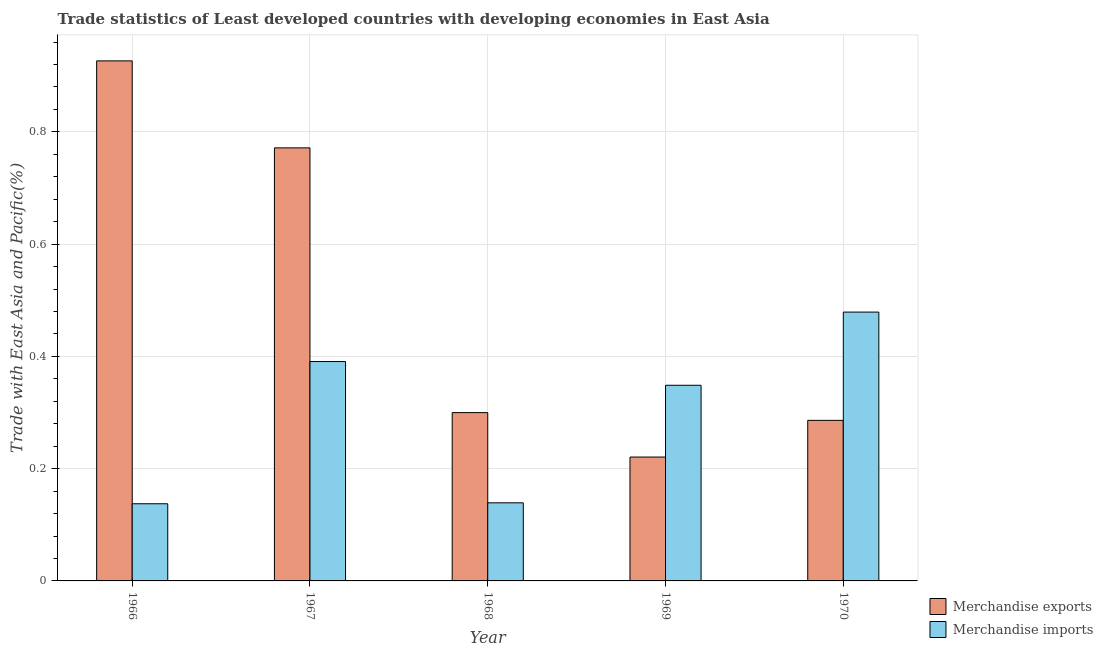How many groups of bars are there?
Ensure brevity in your answer.  5. How many bars are there on the 2nd tick from the left?
Your answer should be very brief. 2. In how many cases, is the number of bars for a given year not equal to the number of legend labels?
Your answer should be compact. 0. What is the merchandise exports in 1970?
Your answer should be very brief. 0.29. Across all years, what is the maximum merchandise imports?
Offer a terse response. 0.48. Across all years, what is the minimum merchandise imports?
Give a very brief answer. 0.14. In which year was the merchandise exports maximum?
Keep it short and to the point. 1966. In which year was the merchandise exports minimum?
Ensure brevity in your answer.  1969. What is the total merchandise imports in the graph?
Your answer should be very brief. 1.49. What is the difference between the merchandise imports in 1967 and that in 1970?
Your response must be concise. -0.09. What is the difference between the merchandise exports in 1966 and the merchandise imports in 1967?
Keep it short and to the point. 0.15. What is the average merchandise imports per year?
Make the answer very short. 0.3. In how many years, is the merchandise imports greater than 0.04 %?
Ensure brevity in your answer.  5. What is the ratio of the merchandise imports in 1966 to that in 1968?
Your answer should be very brief. 0.99. Is the difference between the merchandise exports in 1967 and 1970 greater than the difference between the merchandise imports in 1967 and 1970?
Ensure brevity in your answer.  No. What is the difference between the highest and the second highest merchandise exports?
Keep it short and to the point. 0.15. What is the difference between the highest and the lowest merchandise imports?
Make the answer very short. 0.34. Is the sum of the merchandise exports in 1966 and 1970 greater than the maximum merchandise imports across all years?
Your response must be concise. Yes. What does the 2nd bar from the left in 1967 represents?
Offer a terse response. Merchandise imports. Are all the bars in the graph horizontal?
Keep it short and to the point. No. Are the values on the major ticks of Y-axis written in scientific E-notation?
Ensure brevity in your answer.  No. Does the graph contain any zero values?
Your answer should be compact. No. Does the graph contain grids?
Make the answer very short. Yes. How are the legend labels stacked?
Provide a short and direct response. Vertical. What is the title of the graph?
Keep it short and to the point. Trade statistics of Least developed countries with developing economies in East Asia. What is the label or title of the Y-axis?
Ensure brevity in your answer.  Trade with East Asia and Pacific(%). What is the Trade with East Asia and Pacific(%) in Merchandise exports in 1966?
Your response must be concise. 0.93. What is the Trade with East Asia and Pacific(%) of Merchandise imports in 1966?
Keep it short and to the point. 0.14. What is the Trade with East Asia and Pacific(%) of Merchandise exports in 1967?
Make the answer very short. 0.77. What is the Trade with East Asia and Pacific(%) of Merchandise imports in 1967?
Make the answer very short. 0.39. What is the Trade with East Asia and Pacific(%) in Merchandise exports in 1968?
Your response must be concise. 0.3. What is the Trade with East Asia and Pacific(%) of Merchandise imports in 1968?
Your answer should be compact. 0.14. What is the Trade with East Asia and Pacific(%) of Merchandise exports in 1969?
Keep it short and to the point. 0.22. What is the Trade with East Asia and Pacific(%) of Merchandise imports in 1969?
Offer a very short reply. 0.35. What is the Trade with East Asia and Pacific(%) of Merchandise exports in 1970?
Ensure brevity in your answer.  0.29. What is the Trade with East Asia and Pacific(%) of Merchandise imports in 1970?
Your response must be concise. 0.48. Across all years, what is the maximum Trade with East Asia and Pacific(%) in Merchandise exports?
Offer a very short reply. 0.93. Across all years, what is the maximum Trade with East Asia and Pacific(%) in Merchandise imports?
Keep it short and to the point. 0.48. Across all years, what is the minimum Trade with East Asia and Pacific(%) of Merchandise exports?
Give a very brief answer. 0.22. Across all years, what is the minimum Trade with East Asia and Pacific(%) in Merchandise imports?
Provide a short and direct response. 0.14. What is the total Trade with East Asia and Pacific(%) of Merchandise exports in the graph?
Your response must be concise. 2.5. What is the total Trade with East Asia and Pacific(%) in Merchandise imports in the graph?
Your response must be concise. 1.49. What is the difference between the Trade with East Asia and Pacific(%) of Merchandise exports in 1966 and that in 1967?
Ensure brevity in your answer.  0.15. What is the difference between the Trade with East Asia and Pacific(%) in Merchandise imports in 1966 and that in 1967?
Offer a terse response. -0.25. What is the difference between the Trade with East Asia and Pacific(%) of Merchandise exports in 1966 and that in 1968?
Your answer should be compact. 0.63. What is the difference between the Trade with East Asia and Pacific(%) in Merchandise imports in 1966 and that in 1968?
Your answer should be very brief. -0. What is the difference between the Trade with East Asia and Pacific(%) of Merchandise exports in 1966 and that in 1969?
Your answer should be very brief. 0.71. What is the difference between the Trade with East Asia and Pacific(%) of Merchandise imports in 1966 and that in 1969?
Offer a very short reply. -0.21. What is the difference between the Trade with East Asia and Pacific(%) in Merchandise exports in 1966 and that in 1970?
Offer a very short reply. 0.64. What is the difference between the Trade with East Asia and Pacific(%) in Merchandise imports in 1966 and that in 1970?
Your answer should be very brief. -0.34. What is the difference between the Trade with East Asia and Pacific(%) of Merchandise exports in 1967 and that in 1968?
Your answer should be very brief. 0.47. What is the difference between the Trade with East Asia and Pacific(%) in Merchandise imports in 1967 and that in 1968?
Offer a terse response. 0.25. What is the difference between the Trade with East Asia and Pacific(%) of Merchandise exports in 1967 and that in 1969?
Your answer should be compact. 0.55. What is the difference between the Trade with East Asia and Pacific(%) in Merchandise imports in 1967 and that in 1969?
Offer a terse response. 0.04. What is the difference between the Trade with East Asia and Pacific(%) in Merchandise exports in 1967 and that in 1970?
Your answer should be very brief. 0.49. What is the difference between the Trade with East Asia and Pacific(%) of Merchandise imports in 1967 and that in 1970?
Provide a succinct answer. -0.09. What is the difference between the Trade with East Asia and Pacific(%) of Merchandise exports in 1968 and that in 1969?
Provide a short and direct response. 0.08. What is the difference between the Trade with East Asia and Pacific(%) of Merchandise imports in 1968 and that in 1969?
Offer a very short reply. -0.21. What is the difference between the Trade with East Asia and Pacific(%) of Merchandise exports in 1968 and that in 1970?
Provide a short and direct response. 0.01. What is the difference between the Trade with East Asia and Pacific(%) in Merchandise imports in 1968 and that in 1970?
Keep it short and to the point. -0.34. What is the difference between the Trade with East Asia and Pacific(%) in Merchandise exports in 1969 and that in 1970?
Make the answer very short. -0.07. What is the difference between the Trade with East Asia and Pacific(%) in Merchandise imports in 1969 and that in 1970?
Keep it short and to the point. -0.13. What is the difference between the Trade with East Asia and Pacific(%) of Merchandise exports in 1966 and the Trade with East Asia and Pacific(%) of Merchandise imports in 1967?
Your answer should be compact. 0.54. What is the difference between the Trade with East Asia and Pacific(%) in Merchandise exports in 1966 and the Trade with East Asia and Pacific(%) in Merchandise imports in 1968?
Keep it short and to the point. 0.79. What is the difference between the Trade with East Asia and Pacific(%) of Merchandise exports in 1966 and the Trade with East Asia and Pacific(%) of Merchandise imports in 1969?
Provide a short and direct response. 0.58. What is the difference between the Trade with East Asia and Pacific(%) in Merchandise exports in 1966 and the Trade with East Asia and Pacific(%) in Merchandise imports in 1970?
Offer a very short reply. 0.45. What is the difference between the Trade with East Asia and Pacific(%) of Merchandise exports in 1967 and the Trade with East Asia and Pacific(%) of Merchandise imports in 1968?
Your answer should be compact. 0.63. What is the difference between the Trade with East Asia and Pacific(%) in Merchandise exports in 1967 and the Trade with East Asia and Pacific(%) in Merchandise imports in 1969?
Your answer should be compact. 0.42. What is the difference between the Trade with East Asia and Pacific(%) in Merchandise exports in 1967 and the Trade with East Asia and Pacific(%) in Merchandise imports in 1970?
Your answer should be very brief. 0.29. What is the difference between the Trade with East Asia and Pacific(%) of Merchandise exports in 1968 and the Trade with East Asia and Pacific(%) of Merchandise imports in 1969?
Keep it short and to the point. -0.05. What is the difference between the Trade with East Asia and Pacific(%) in Merchandise exports in 1968 and the Trade with East Asia and Pacific(%) in Merchandise imports in 1970?
Your response must be concise. -0.18. What is the difference between the Trade with East Asia and Pacific(%) in Merchandise exports in 1969 and the Trade with East Asia and Pacific(%) in Merchandise imports in 1970?
Your response must be concise. -0.26. What is the average Trade with East Asia and Pacific(%) of Merchandise exports per year?
Offer a very short reply. 0.5. What is the average Trade with East Asia and Pacific(%) of Merchandise imports per year?
Provide a succinct answer. 0.3. In the year 1966, what is the difference between the Trade with East Asia and Pacific(%) of Merchandise exports and Trade with East Asia and Pacific(%) of Merchandise imports?
Your answer should be very brief. 0.79. In the year 1967, what is the difference between the Trade with East Asia and Pacific(%) of Merchandise exports and Trade with East Asia and Pacific(%) of Merchandise imports?
Your answer should be very brief. 0.38. In the year 1968, what is the difference between the Trade with East Asia and Pacific(%) of Merchandise exports and Trade with East Asia and Pacific(%) of Merchandise imports?
Make the answer very short. 0.16. In the year 1969, what is the difference between the Trade with East Asia and Pacific(%) of Merchandise exports and Trade with East Asia and Pacific(%) of Merchandise imports?
Provide a succinct answer. -0.13. In the year 1970, what is the difference between the Trade with East Asia and Pacific(%) of Merchandise exports and Trade with East Asia and Pacific(%) of Merchandise imports?
Give a very brief answer. -0.19. What is the ratio of the Trade with East Asia and Pacific(%) of Merchandise exports in 1966 to that in 1967?
Give a very brief answer. 1.2. What is the ratio of the Trade with East Asia and Pacific(%) in Merchandise imports in 1966 to that in 1967?
Your response must be concise. 0.35. What is the ratio of the Trade with East Asia and Pacific(%) in Merchandise exports in 1966 to that in 1968?
Your response must be concise. 3.09. What is the ratio of the Trade with East Asia and Pacific(%) in Merchandise imports in 1966 to that in 1968?
Your response must be concise. 0.99. What is the ratio of the Trade with East Asia and Pacific(%) of Merchandise exports in 1966 to that in 1969?
Keep it short and to the point. 4.2. What is the ratio of the Trade with East Asia and Pacific(%) in Merchandise imports in 1966 to that in 1969?
Provide a short and direct response. 0.39. What is the ratio of the Trade with East Asia and Pacific(%) in Merchandise exports in 1966 to that in 1970?
Offer a very short reply. 3.24. What is the ratio of the Trade with East Asia and Pacific(%) of Merchandise imports in 1966 to that in 1970?
Your answer should be very brief. 0.29. What is the ratio of the Trade with East Asia and Pacific(%) of Merchandise exports in 1967 to that in 1968?
Give a very brief answer. 2.57. What is the ratio of the Trade with East Asia and Pacific(%) of Merchandise imports in 1967 to that in 1968?
Your answer should be compact. 2.81. What is the ratio of the Trade with East Asia and Pacific(%) of Merchandise exports in 1967 to that in 1969?
Offer a terse response. 3.5. What is the ratio of the Trade with East Asia and Pacific(%) of Merchandise imports in 1967 to that in 1969?
Your answer should be very brief. 1.12. What is the ratio of the Trade with East Asia and Pacific(%) in Merchandise exports in 1967 to that in 1970?
Provide a succinct answer. 2.7. What is the ratio of the Trade with East Asia and Pacific(%) of Merchandise imports in 1967 to that in 1970?
Ensure brevity in your answer.  0.82. What is the ratio of the Trade with East Asia and Pacific(%) of Merchandise exports in 1968 to that in 1969?
Offer a terse response. 1.36. What is the ratio of the Trade with East Asia and Pacific(%) in Merchandise imports in 1968 to that in 1969?
Keep it short and to the point. 0.4. What is the ratio of the Trade with East Asia and Pacific(%) in Merchandise exports in 1968 to that in 1970?
Provide a short and direct response. 1.05. What is the ratio of the Trade with East Asia and Pacific(%) of Merchandise imports in 1968 to that in 1970?
Offer a terse response. 0.29. What is the ratio of the Trade with East Asia and Pacific(%) in Merchandise exports in 1969 to that in 1970?
Provide a succinct answer. 0.77. What is the ratio of the Trade with East Asia and Pacific(%) in Merchandise imports in 1969 to that in 1970?
Provide a succinct answer. 0.73. What is the difference between the highest and the second highest Trade with East Asia and Pacific(%) in Merchandise exports?
Provide a short and direct response. 0.15. What is the difference between the highest and the second highest Trade with East Asia and Pacific(%) in Merchandise imports?
Ensure brevity in your answer.  0.09. What is the difference between the highest and the lowest Trade with East Asia and Pacific(%) of Merchandise exports?
Your answer should be compact. 0.71. What is the difference between the highest and the lowest Trade with East Asia and Pacific(%) in Merchandise imports?
Offer a terse response. 0.34. 